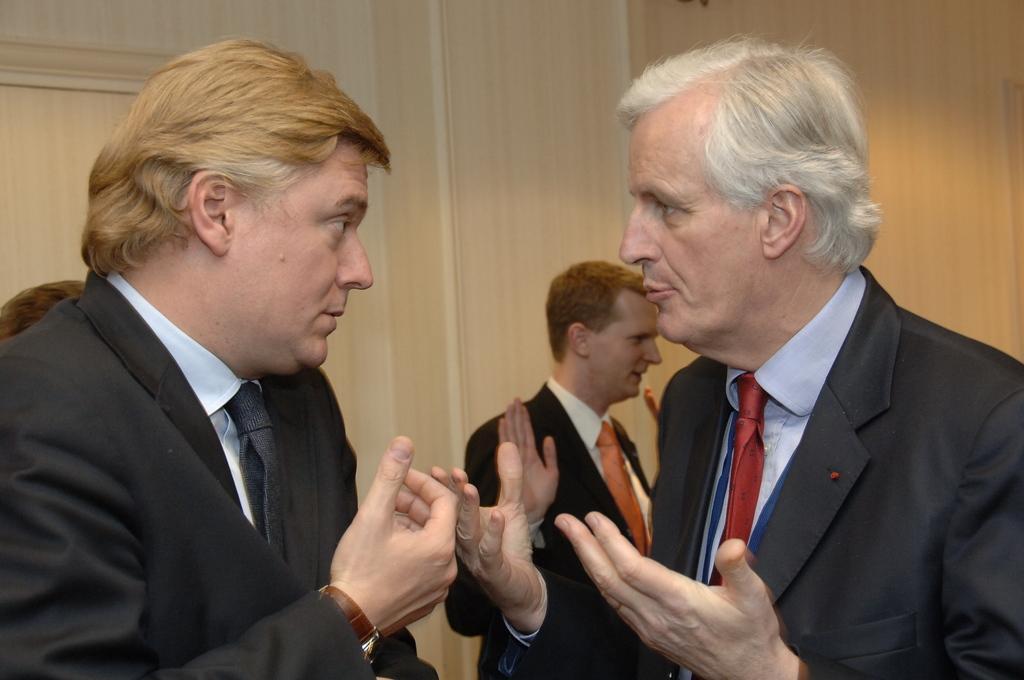How would you summarize this image in a sentence or two? In this image we can see man standing. In the background there are walls. 